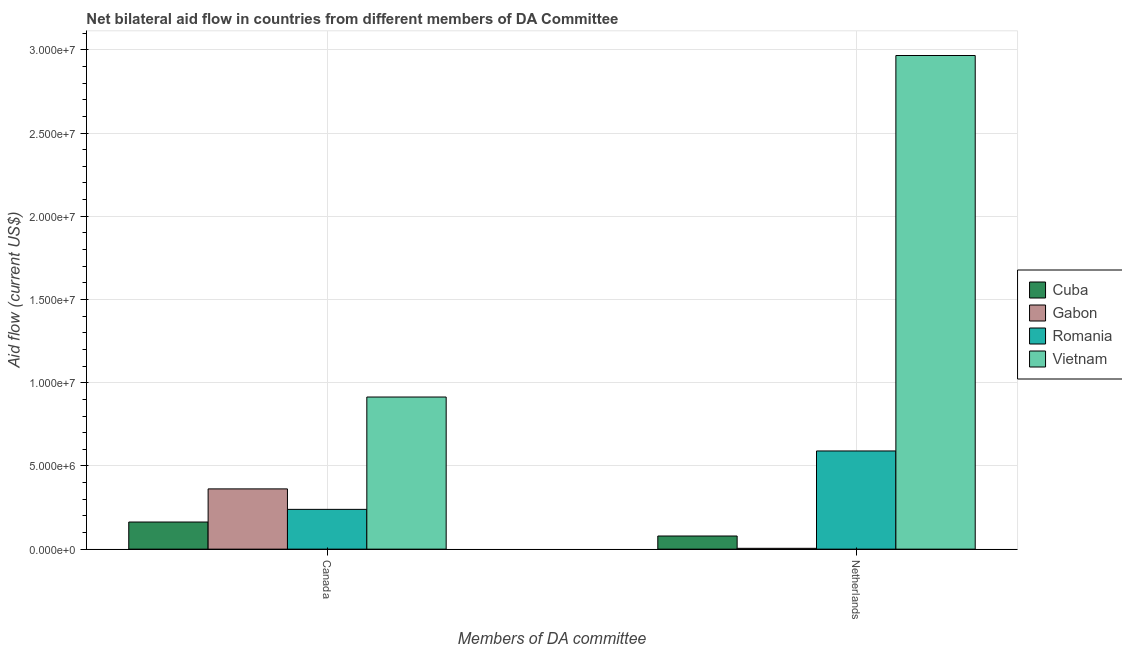How many groups of bars are there?
Offer a terse response. 2. How many bars are there on the 2nd tick from the right?
Offer a very short reply. 4. What is the amount of aid given by canada in Vietnam?
Offer a very short reply. 9.14e+06. Across all countries, what is the maximum amount of aid given by netherlands?
Your response must be concise. 2.97e+07. Across all countries, what is the minimum amount of aid given by canada?
Keep it short and to the point. 1.63e+06. In which country was the amount of aid given by canada maximum?
Offer a very short reply. Vietnam. In which country was the amount of aid given by canada minimum?
Your response must be concise. Cuba. What is the total amount of aid given by netherlands in the graph?
Ensure brevity in your answer.  3.64e+07. What is the difference between the amount of aid given by netherlands in Vietnam and that in Gabon?
Your answer should be compact. 2.96e+07. What is the difference between the amount of aid given by netherlands in Cuba and the amount of aid given by canada in Romania?
Give a very brief answer. -1.60e+06. What is the average amount of aid given by netherlands per country?
Offer a very short reply. 9.10e+06. What is the difference between the amount of aid given by canada and amount of aid given by netherlands in Vietnam?
Make the answer very short. -2.05e+07. What is the ratio of the amount of aid given by netherlands in Romania to that in Vietnam?
Provide a short and direct response. 0.2. In how many countries, is the amount of aid given by netherlands greater than the average amount of aid given by netherlands taken over all countries?
Ensure brevity in your answer.  1. What does the 1st bar from the left in Netherlands represents?
Your answer should be compact. Cuba. What does the 4th bar from the right in Canada represents?
Provide a short and direct response. Cuba. Are all the bars in the graph horizontal?
Ensure brevity in your answer.  No. How many countries are there in the graph?
Give a very brief answer. 4. What is the difference between two consecutive major ticks on the Y-axis?
Ensure brevity in your answer.  5.00e+06. Are the values on the major ticks of Y-axis written in scientific E-notation?
Provide a short and direct response. Yes. Does the graph contain any zero values?
Your answer should be very brief. No. How are the legend labels stacked?
Your response must be concise. Vertical. What is the title of the graph?
Make the answer very short. Net bilateral aid flow in countries from different members of DA Committee. What is the label or title of the X-axis?
Your response must be concise. Members of DA committee. What is the label or title of the Y-axis?
Keep it short and to the point. Aid flow (current US$). What is the Aid flow (current US$) in Cuba in Canada?
Provide a short and direct response. 1.63e+06. What is the Aid flow (current US$) in Gabon in Canada?
Ensure brevity in your answer.  3.62e+06. What is the Aid flow (current US$) of Romania in Canada?
Keep it short and to the point. 2.39e+06. What is the Aid flow (current US$) in Vietnam in Canada?
Your answer should be very brief. 9.14e+06. What is the Aid flow (current US$) of Cuba in Netherlands?
Make the answer very short. 7.90e+05. What is the Aid flow (current US$) of Romania in Netherlands?
Offer a very short reply. 5.90e+06. What is the Aid flow (current US$) in Vietnam in Netherlands?
Offer a terse response. 2.97e+07. Across all Members of DA committee, what is the maximum Aid flow (current US$) in Cuba?
Offer a terse response. 1.63e+06. Across all Members of DA committee, what is the maximum Aid flow (current US$) in Gabon?
Provide a short and direct response. 3.62e+06. Across all Members of DA committee, what is the maximum Aid flow (current US$) of Romania?
Offer a very short reply. 5.90e+06. Across all Members of DA committee, what is the maximum Aid flow (current US$) in Vietnam?
Give a very brief answer. 2.97e+07. Across all Members of DA committee, what is the minimum Aid flow (current US$) in Cuba?
Offer a very short reply. 7.90e+05. Across all Members of DA committee, what is the minimum Aid flow (current US$) in Gabon?
Your answer should be compact. 5.00e+04. Across all Members of DA committee, what is the minimum Aid flow (current US$) in Romania?
Ensure brevity in your answer.  2.39e+06. Across all Members of DA committee, what is the minimum Aid flow (current US$) of Vietnam?
Ensure brevity in your answer.  9.14e+06. What is the total Aid flow (current US$) in Cuba in the graph?
Offer a very short reply. 2.42e+06. What is the total Aid flow (current US$) in Gabon in the graph?
Give a very brief answer. 3.67e+06. What is the total Aid flow (current US$) in Romania in the graph?
Offer a very short reply. 8.29e+06. What is the total Aid flow (current US$) of Vietnam in the graph?
Make the answer very short. 3.88e+07. What is the difference between the Aid flow (current US$) in Cuba in Canada and that in Netherlands?
Provide a short and direct response. 8.40e+05. What is the difference between the Aid flow (current US$) in Gabon in Canada and that in Netherlands?
Provide a short and direct response. 3.57e+06. What is the difference between the Aid flow (current US$) in Romania in Canada and that in Netherlands?
Ensure brevity in your answer.  -3.51e+06. What is the difference between the Aid flow (current US$) in Vietnam in Canada and that in Netherlands?
Your answer should be very brief. -2.05e+07. What is the difference between the Aid flow (current US$) in Cuba in Canada and the Aid flow (current US$) in Gabon in Netherlands?
Provide a short and direct response. 1.58e+06. What is the difference between the Aid flow (current US$) of Cuba in Canada and the Aid flow (current US$) of Romania in Netherlands?
Your answer should be compact. -4.27e+06. What is the difference between the Aid flow (current US$) in Cuba in Canada and the Aid flow (current US$) in Vietnam in Netherlands?
Offer a very short reply. -2.80e+07. What is the difference between the Aid flow (current US$) in Gabon in Canada and the Aid flow (current US$) in Romania in Netherlands?
Make the answer very short. -2.28e+06. What is the difference between the Aid flow (current US$) in Gabon in Canada and the Aid flow (current US$) in Vietnam in Netherlands?
Your answer should be compact. -2.60e+07. What is the difference between the Aid flow (current US$) of Romania in Canada and the Aid flow (current US$) of Vietnam in Netherlands?
Keep it short and to the point. -2.73e+07. What is the average Aid flow (current US$) in Cuba per Members of DA committee?
Keep it short and to the point. 1.21e+06. What is the average Aid flow (current US$) of Gabon per Members of DA committee?
Ensure brevity in your answer.  1.84e+06. What is the average Aid flow (current US$) of Romania per Members of DA committee?
Your answer should be very brief. 4.14e+06. What is the average Aid flow (current US$) in Vietnam per Members of DA committee?
Provide a short and direct response. 1.94e+07. What is the difference between the Aid flow (current US$) of Cuba and Aid flow (current US$) of Gabon in Canada?
Provide a succinct answer. -1.99e+06. What is the difference between the Aid flow (current US$) of Cuba and Aid flow (current US$) of Romania in Canada?
Your answer should be compact. -7.60e+05. What is the difference between the Aid flow (current US$) in Cuba and Aid flow (current US$) in Vietnam in Canada?
Offer a very short reply. -7.51e+06. What is the difference between the Aid flow (current US$) of Gabon and Aid flow (current US$) of Romania in Canada?
Offer a terse response. 1.23e+06. What is the difference between the Aid flow (current US$) in Gabon and Aid flow (current US$) in Vietnam in Canada?
Keep it short and to the point. -5.52e+06. What is the difference between the Aid flow (current US$) in Romania and Aid flow (current US$) in Vietnam in Canada?
Make the answer very short. -6.75e+06. What is the difference between the Aid flow (current US$) in Cuba and Aid flow (current US$) in Gabon in Netherlands?
Offer a terse response. 7.40e+05. What is the difference between the Aid flow (current US$) in Cuba and Aid flow (current US$) in Romania in Netherlands?
Your answer should be compact. -5.11e+06. What is the difference between the Aid flow (current US$) of Cuba and Aid flow (current US$) of Vietnam in Netherlands?
Keep it short and to the point. -2.89e+07. What is the difference between the Aid flow (current US$) of Gabon and Aid flow (current US$) of Romania in Netherlands?
Offer a very short reply. -5.85e+06. What is the difference between the Aid flow (current US$) of Gabon and Aid flow (current US$) of Vietnam in Netherlands?
Your response must be concise. -2.96e+07. What is the difference between the Aid flow (current US$) in Romania and Aid flow (current US$) in Vietnam in Netherlands?
Make the answer very short. -2.38e+07. What is the ratio of the Aid flow (current US$) in Cuba in Canada to that in Netherlands?
Give a very brief answer. 2.06. What is the ratio of the Aid flow (current US$) in Gabon in Canada to that in Netherlands?
Offer a terse response. 72.4. What is the ratio of the Aid flow (current US$) of Romania in Canada to that in Netherlands?
Make the answer very short. 0.41. What is the ratio of the Aid flow (current US$) of Vietnam in Canada to that in Netherlands?
Your response must be concise. 0.31. What is the difference between the highest and the second highest Aid flow (current US$) of Cuba?
Your answer should be very brief. 8.40e+05. What is the difference between the highest and the second highest Aid flow (current US$) of Gabon?
Offer a very short reply. 3.57e+06. What is the difference between the highest and the second highest Aid flow (current US$) in Romania?
Your answer should be very brief. 3.51e+06. What is the difference between the highest and the second highest Aid flow (current US$) of Vietnam?
Ensure brevity in your answer.  2.05e+07. What is the difference between the highest and the lowest Aid flow (current US$) of Cuba?
Your answer should be compact. 8.40e+05. What is the difference between the highest and the lowest Aid flow (current US$) in Gabon?
Your answer should be very brief. 3.57e+06. What is the difference between the highest and the lowest Aid flow (current US$) of Romania?
Keep it short and to the point. 3.51e+06. What is the difference between the highest and the lowest Aid flow (current US$) in Vietnam?
Offer a very short reply. 2.05e+07. 